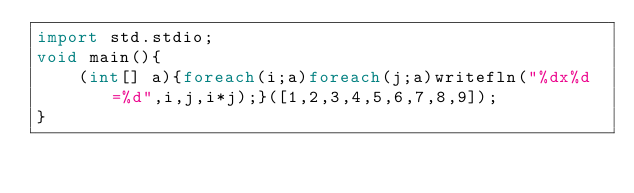<code> <loc_0><loc_0><loc_500><loc_500><_D_>import std.stdio;
void main(){
    (int[] a){foreach(i;a)foreach(j;a)writefln("%dx%d=%d",i,j,i*j);}([1,2,3,4,5,6,7,8,9]);
}</code> 